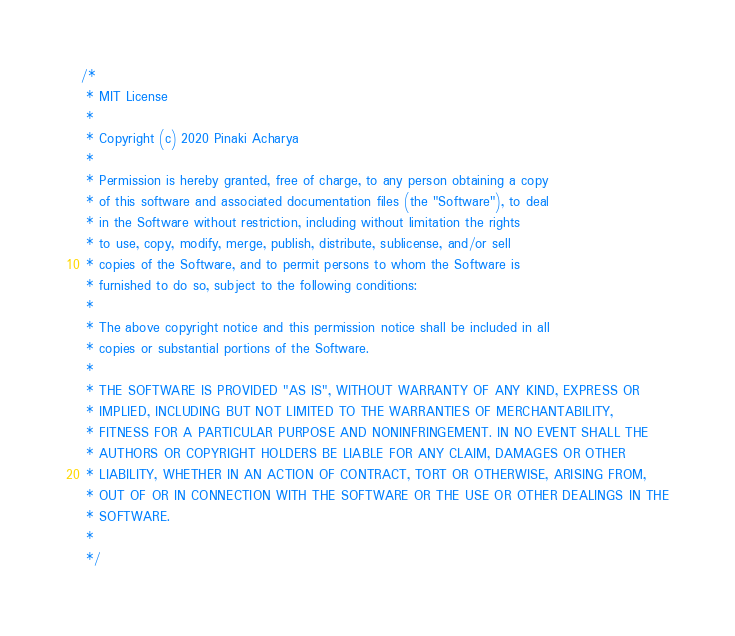Convert code to text. <code><loc_0><loc_0><loc_500><loc_500><_Kotlin_>/*
 * MIT License
 *
 * Copyright (c) 2020 Pinaki Acharya
 *
 * Permission is hereby granted, free of charge, to any person obtaining a copy
 * of this software and associated documentation files (the "Software"), to deal
 * in the Software without restriction, including without limitation the rights
 * to use, copy, modify, merge, publish, distribute, sublicense, and/or sell
 * copies of the Software, and to permit persons to whom the Software is
 * furnished to do so, subject to the following conditions:
 *
 * The above copyright notice and this permission notice shall be included in all
 * copies or substantial portions of the Software.
 *
 * THE SOFTWARE IS PROVIDED "AS IS", WITHOUT WARRANTY OF ANY KIND, EXPRESS OR
 * IMPLIED, INCLUDING BUT NOT LIMITED TO THE WARRANTIES OF MERCHANTABILITY,
 * FITNESS FOR A PARTICULAR PURPOSE AND NONINFRINGEMENT. IN NO EVENT SHALL THE
 * AUTHORS OR COPYRIGHT HOLDERS BE LIABLE FOR ANY CLAIM, DAMAGES OR OTHER
 * LIABILITY, WHETHER IN AN ACTION OF CONTRACT, TORT OR OTHERWISE, ARISING FROM,
 * OUT OF OR IN CONNECTION WITH THE SOFTWARE OR THE USE OR OTHER DEALINGS IN THE
 * SOFTWARE.
 *
 */
</code> 